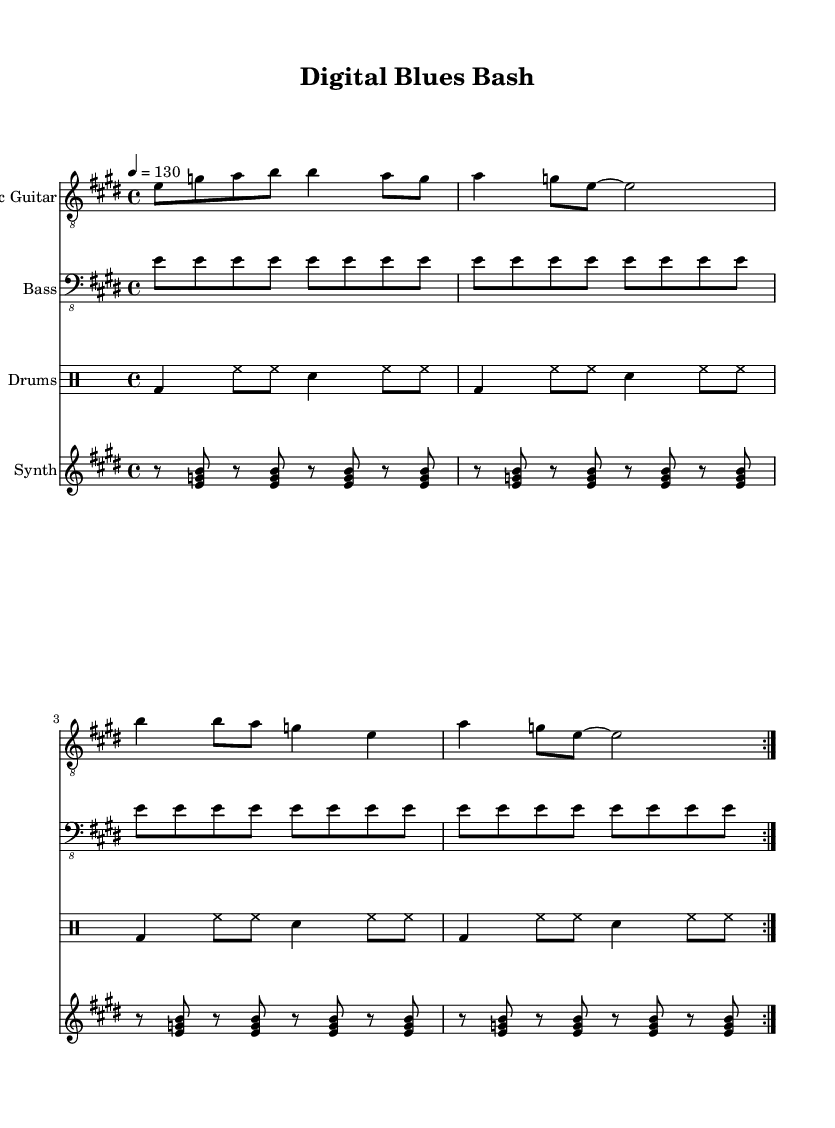What is the key signature of this music? The key signature is E major, which has four sharps (F#, C#, G#, and D#). This can be identified at the beginning of the staff.
Answer: E major What is the time signature of this music? The time signature is 4/4, which means there are four beats in each measure and the quarter note gets one beat. This is displayed at the beginning of the score.
Answer: 4/4 What is the tempo marking of this music? The tempo marking is quarter note equals 130 beats per minute. This can be found above the staff, indicating the speed of the piece.
Answer: 130 How many sections does the electric guitar part repeat? The electric guitar part has two sections indicated by the repeat volta markings. Looking at the score, each section is marked to be played twice.
Answer: 2 Which instruments are included in this composition? The composition includes Electric Guitar, Bass, Drums, and Synth. This is listed in the score under each staff and part.
Answer: Electric Guitar, Bass, Drums, Synth What is the primary rhythmic pattern used in the drums part? The primary rhythmic pattern in the drums part consists of kick drum on beats 1 and 3, with hi-hat playing eighth notes throughout, and a snare on beats 2 and 4. Analyzing the drum part reveals this pattern.
Answer: Kick on 1 & 3, Snare on 2 & 4 What electronic element is used in the synth part? The synth part features a chord progression played in eighth notes with rests, specifically using the notes E, G, and B. This can be observed in the synth staff throughout the measure.
Answer: E, G, B 